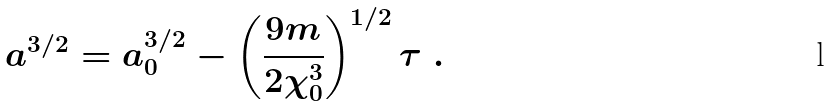<formula> <loc_0><loc_0><loc_500><loc_500>a ^ { 3 / 2 } = a _ { 0 } ^ { 3 / 2 } - \left ( \frac { 9 m } { 2 \chi _ { 0 } ^ { 3 } } \right ) ^ { 1 / 2 } \tau \ .</formula> 